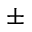Convert formula to latex. <formula><loc_0><loc_0><loc_500><loc_500>\pm</formula> 